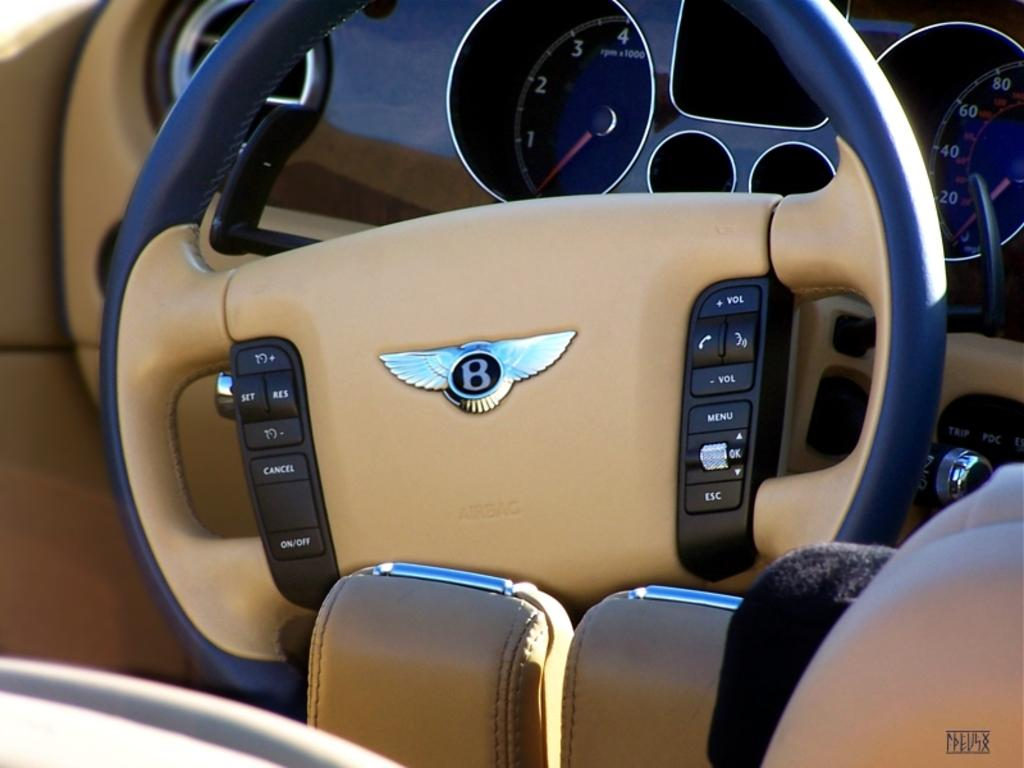What type of space is depicted in the image? The image shows the interior of a vehicle. What is the primary control mechanism in the vehicle? There is a steering wheel in the vehicle. What additional features are present on the steering wheel? The steering wheel has buttons on it. How can the driver monitor their speed in the vehicle? There are speedometers in the vehicle. What is provided for the driver or passengers to sit on in the vehicle? There is a seat in the vehicle. Can you describe any other objects present in the vehicle? There are other objects present in the vehicle, but their specific details are not mentioned in the provided facts. Where can the driver purchase fresh produce while driving in the vehicle? There is no mention of a market or fresh produce in the image, so it is not possible to answer that question. 